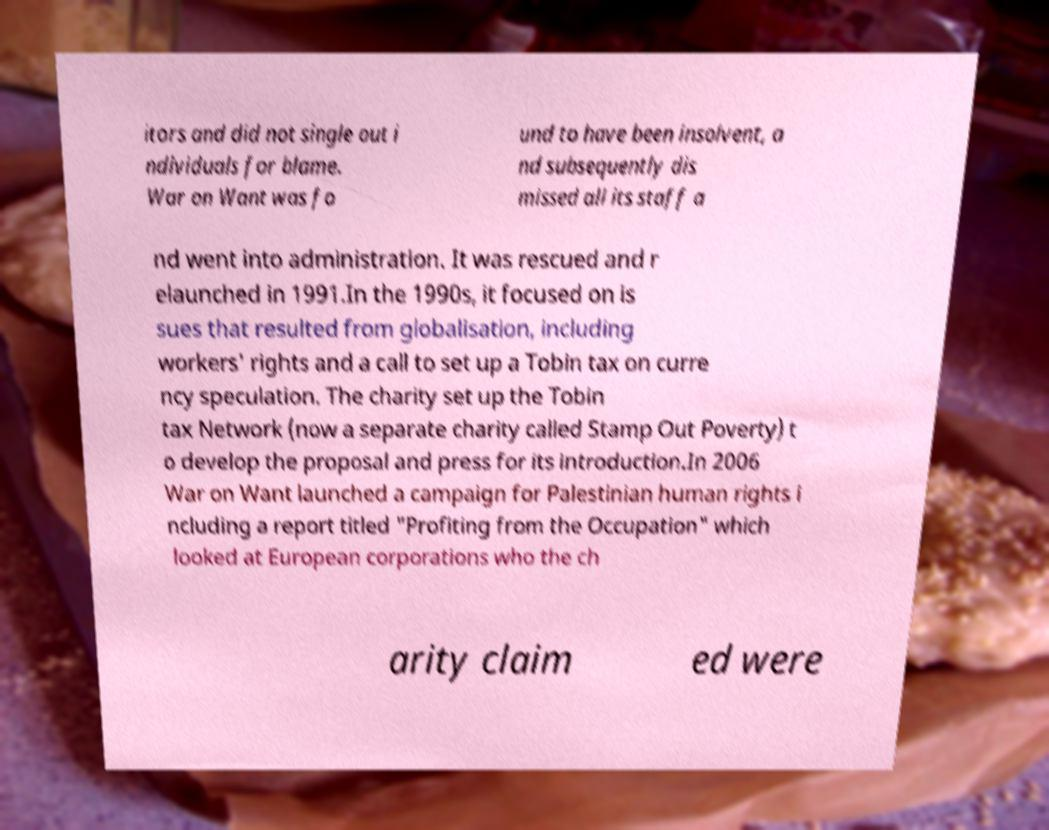Could you assist in decoding the text presented in this image and type it out clearly? itors and did not single out i ndividuals for blame. War on Want was fo und to have been insolvent, a nd subsequently dis missed all its staff a nd went into administration. It was rescued and r elaunched in 1991.In the 1990s, it focused on is sues that resulted from globalisation, including workers' rights and a call to set up a Tobin tax on curre ncy speculation. The charity set up the Tobin tax Network (now a separate charity called Stamp Out Poverty) t o develop the proposal and press for its introduction.In 2006 War on Want launched a campaign for Palestinian human rights i ncluding a report titled "Profiting from the Occupation" which looked at European corporations who the ch arity claim ed were 